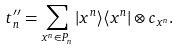<formula> <loc_0><loc_0><loc_500><loc_500>t ^ { \prime \prime } _ { n } = \sum _ { x ^ { n } \in P _ { n } } | x ^ { n } \rangle \langle x ^ { n } | \otimes c _ { x ^ { n } } .</formula> 